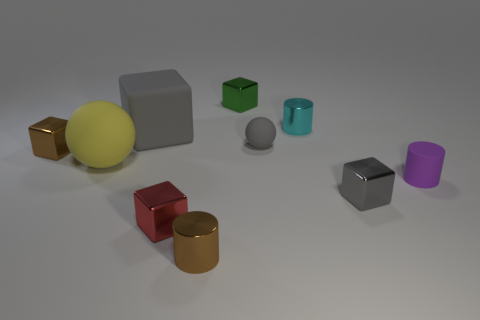The yellow matte object has what size?
Ensure brevity in your answer.  Large. What is the size of the yellow ball that is made of the same material as the big gray object?
Provide a succinct answer. Large. The brown metal object behind the purple object has what shape?
Give a very brief answer. Cube. What color is the rubber ball that is the same size as the red thing?
Give a very brief answer. Gray. There is a small green shiny object; does it have the same shape as the big yellow thing in front of the big gray thing?
Make the answer very short. No. What material is the gray cube in front of the small brown object that is to the left of the small cylinder left of the cyan shiny cylinder?
Provide a short and direct response. Metal. What number of small objects are metal objects or blue metal cylinders?
Your answer should be very brief. 6. How many other objects are there of the same size as the gray shiny block?
Your answer should be very brief. 7. There is a tiny matte object that is left of the cyan metallic cylinder; is its shape the same as the large yellow thing?
Your answer should be compact. Yes. The rubber object that is the same shape as the red metallic object is what color?
Your response must be concise. Gray. 